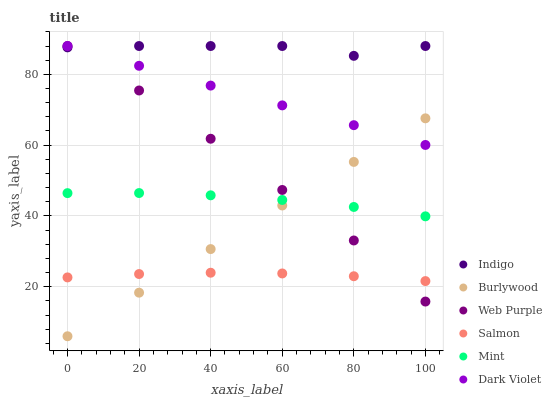Does Salmon have the minimum area under the curve?
Answer yes or no. Yes. Does Indigo have the maximum area under the curve?
Answer yes or no. Yes. Does Burlywood have the minimum area under the curve?
Answer yes or no. No. Does Burlywood have the maximum area under the curve?
Answer yes or no. No. Is Dark Violet the smoothest?
Answer yes or no. Yes. Is Indigo the roughest?
Answer yes or no. Yes. Is Burlywood the smoothest?
Answer yes or no. No. Is Burlywood the roughest?
Answer yes or no. No. Does Burlywood have the lowest value?
Answer yes or no. Yes. Does Salmon have the lowest value?
Answer yes or no. No. Does Web Purple have the highest value?
Answer yes or no. Yes. Does Burlywood have the highest value?
Answer yes or no. No. Is Salmon less than Mint?
Answer yes or no. Yes. Is Indigo greater than Salmon?
Answer yes or no. Yes. Does Burlywood intersect Dark Violet?
Answer yes or no. Yes. Is Burlywood less than Dark Violet?
Answer yes or no. No. Is Burlywood greater than Dark Violet?
Answer yes or no. No. Does Salmon intersect Mint?
Answer yes or no. No. 